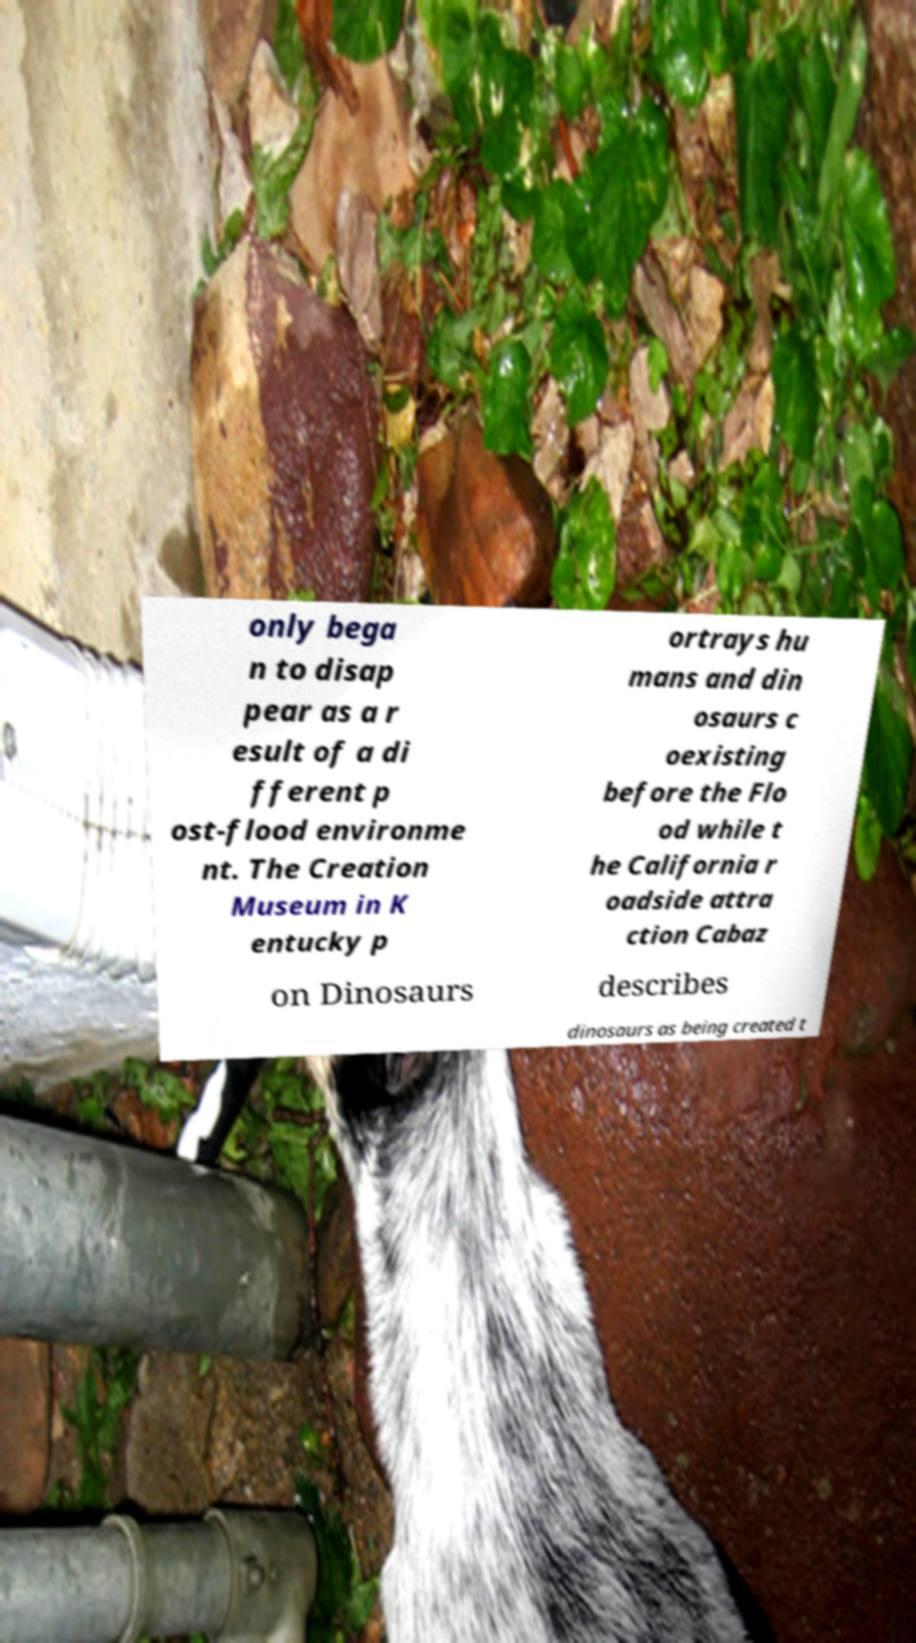There's text embedded in this image that I need extracted. Can you transcribe it verbatim? only bega n to disap pear as a r esult of a di fferent p ost-flood environme nt. The Creation Museum in K entucky p ortrays hu mans and din osaurs c oexisting before the Flo od while t he California r oadside attra ction Cabaz on Dinosaurs describes dinosaurs as being created t 